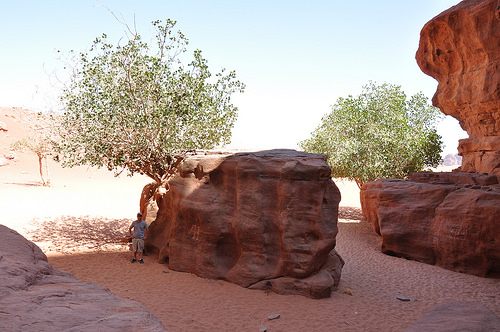<image>
Is the rock to the left of the rock? No. The rock is not to the left of the rock. From this viewpoint, they have a different horizontal relationship. Where is the man in relation to the rock? Is it under the rock? No. The man is not positioned under the rock. The vertical relationship between these objects is different. 